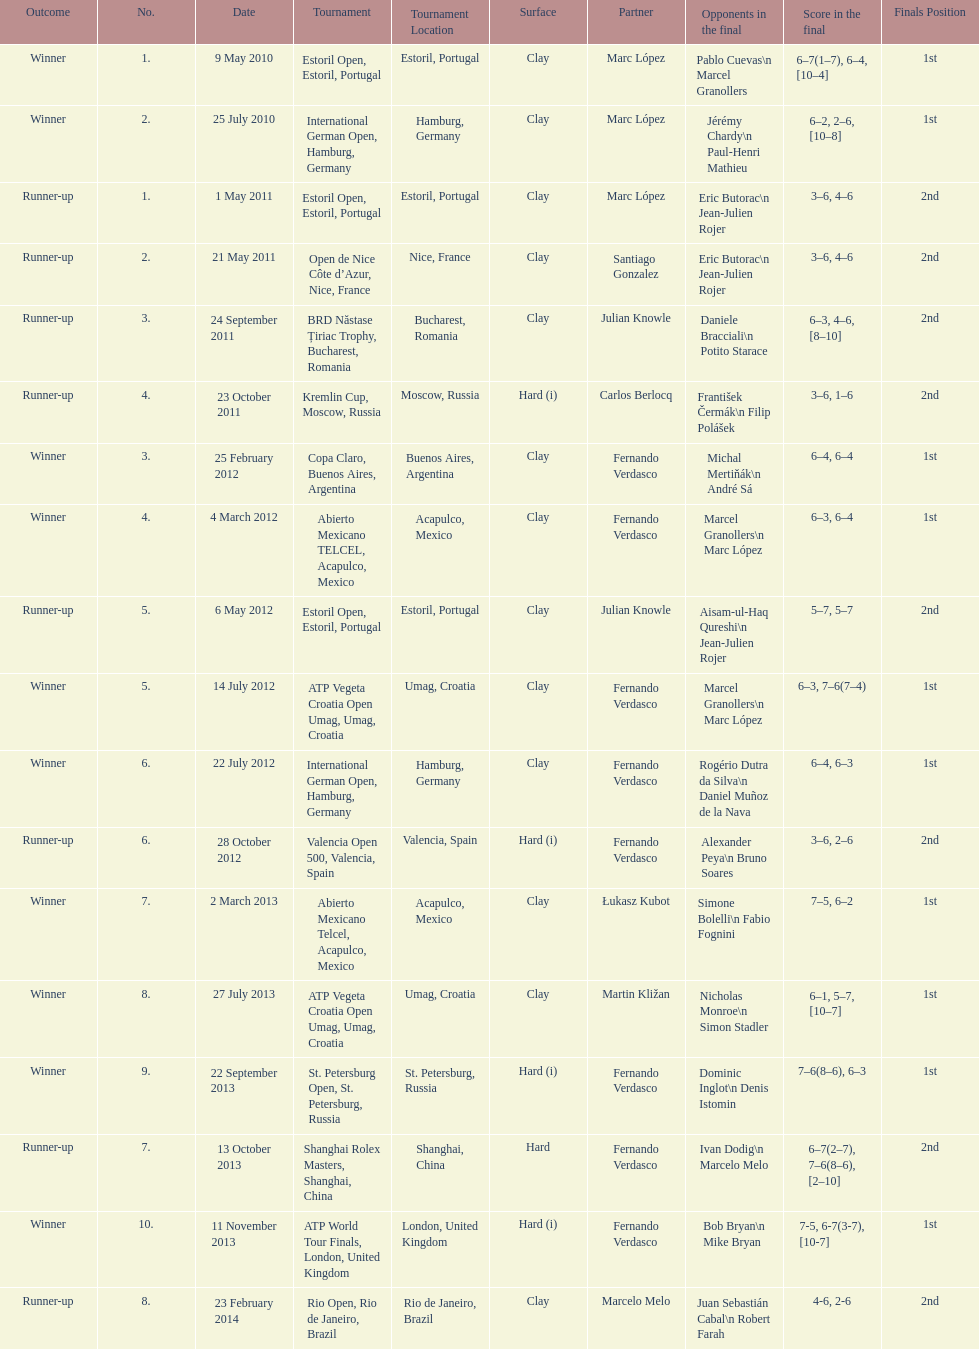What is the number of times a hard surface was used? 5. 